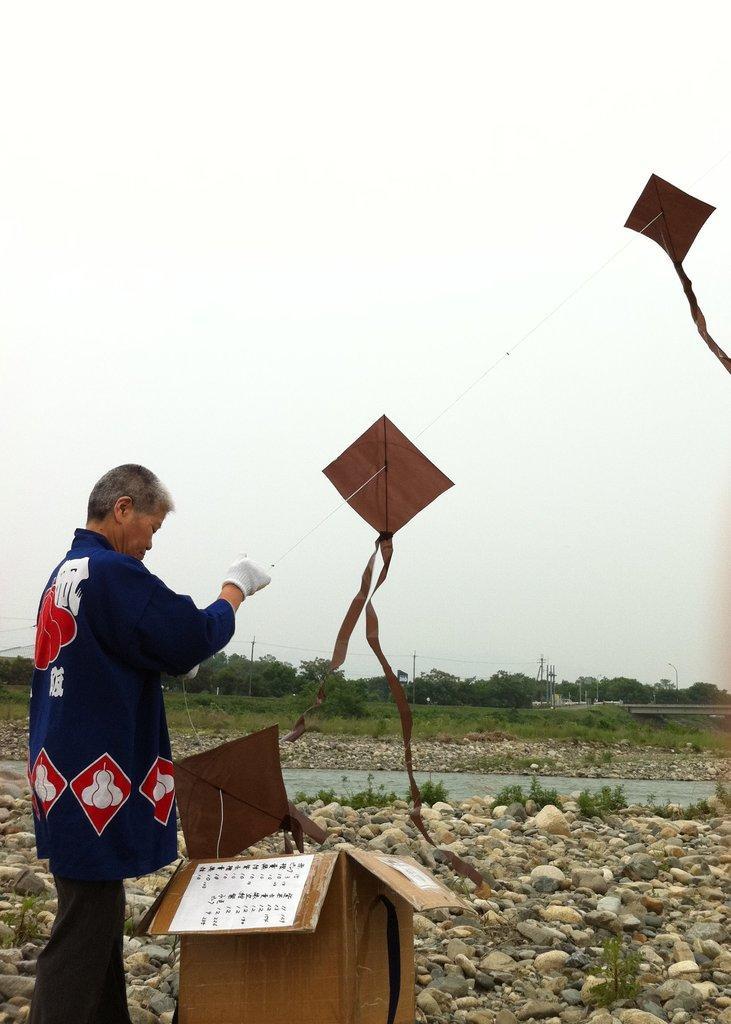Please provide a concise description of this image. In this image I can see a person wearing blue, red and white colored dress is standing and holding a rope in his hand. I can see a cardboard box which is brown in color on the ground and few items which are brown in color flying in the air. I can see some grass, few stones, the water, few trees and few poles. In the background I can see the sky. 